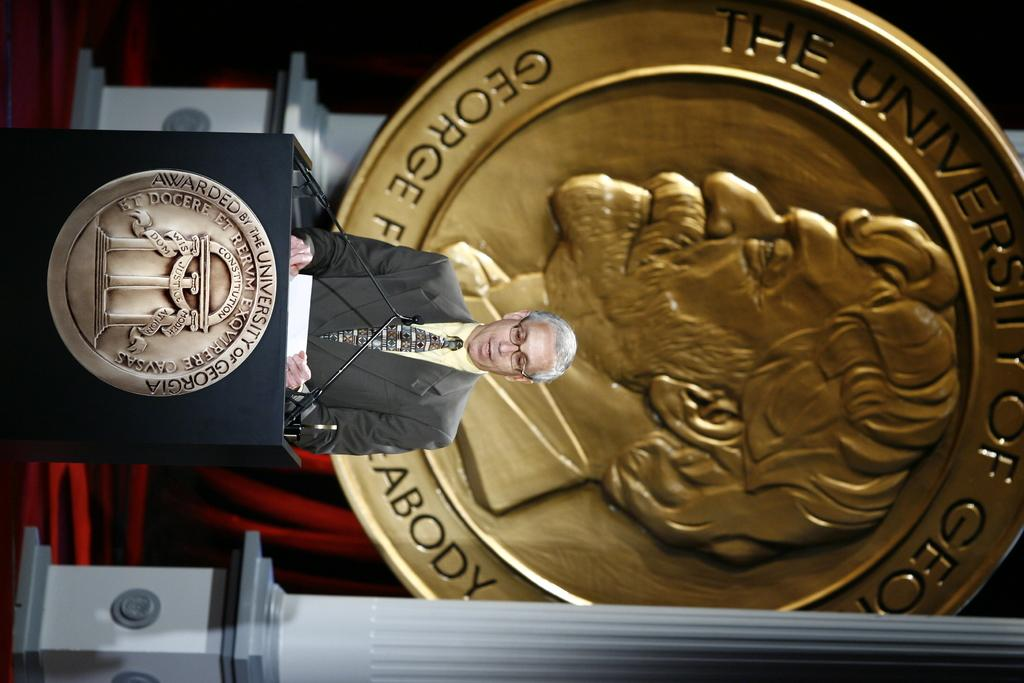<image>
Render a clear and concise summary of the photo. A man stands behind a podium that has a large emblem on the front of it that says awarded by the University of Georgia. 